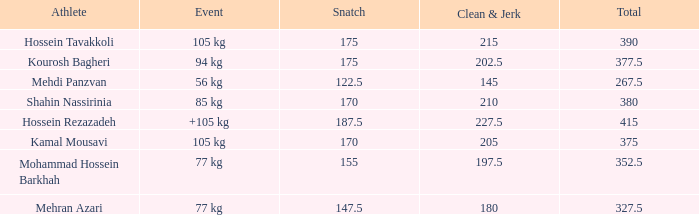How many snatches were there with a total of 267.5? 0.0. 